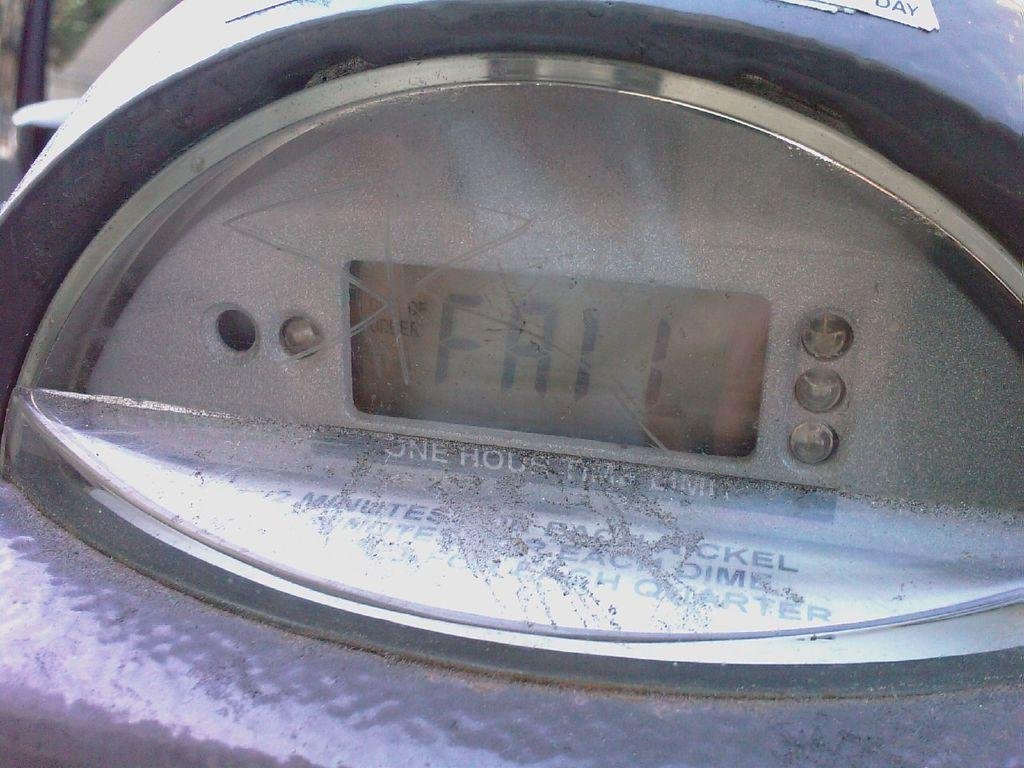<image>
Write a terse but informative summary of the picture. A close up view of the screen of a parking meter that reads FAIL. 